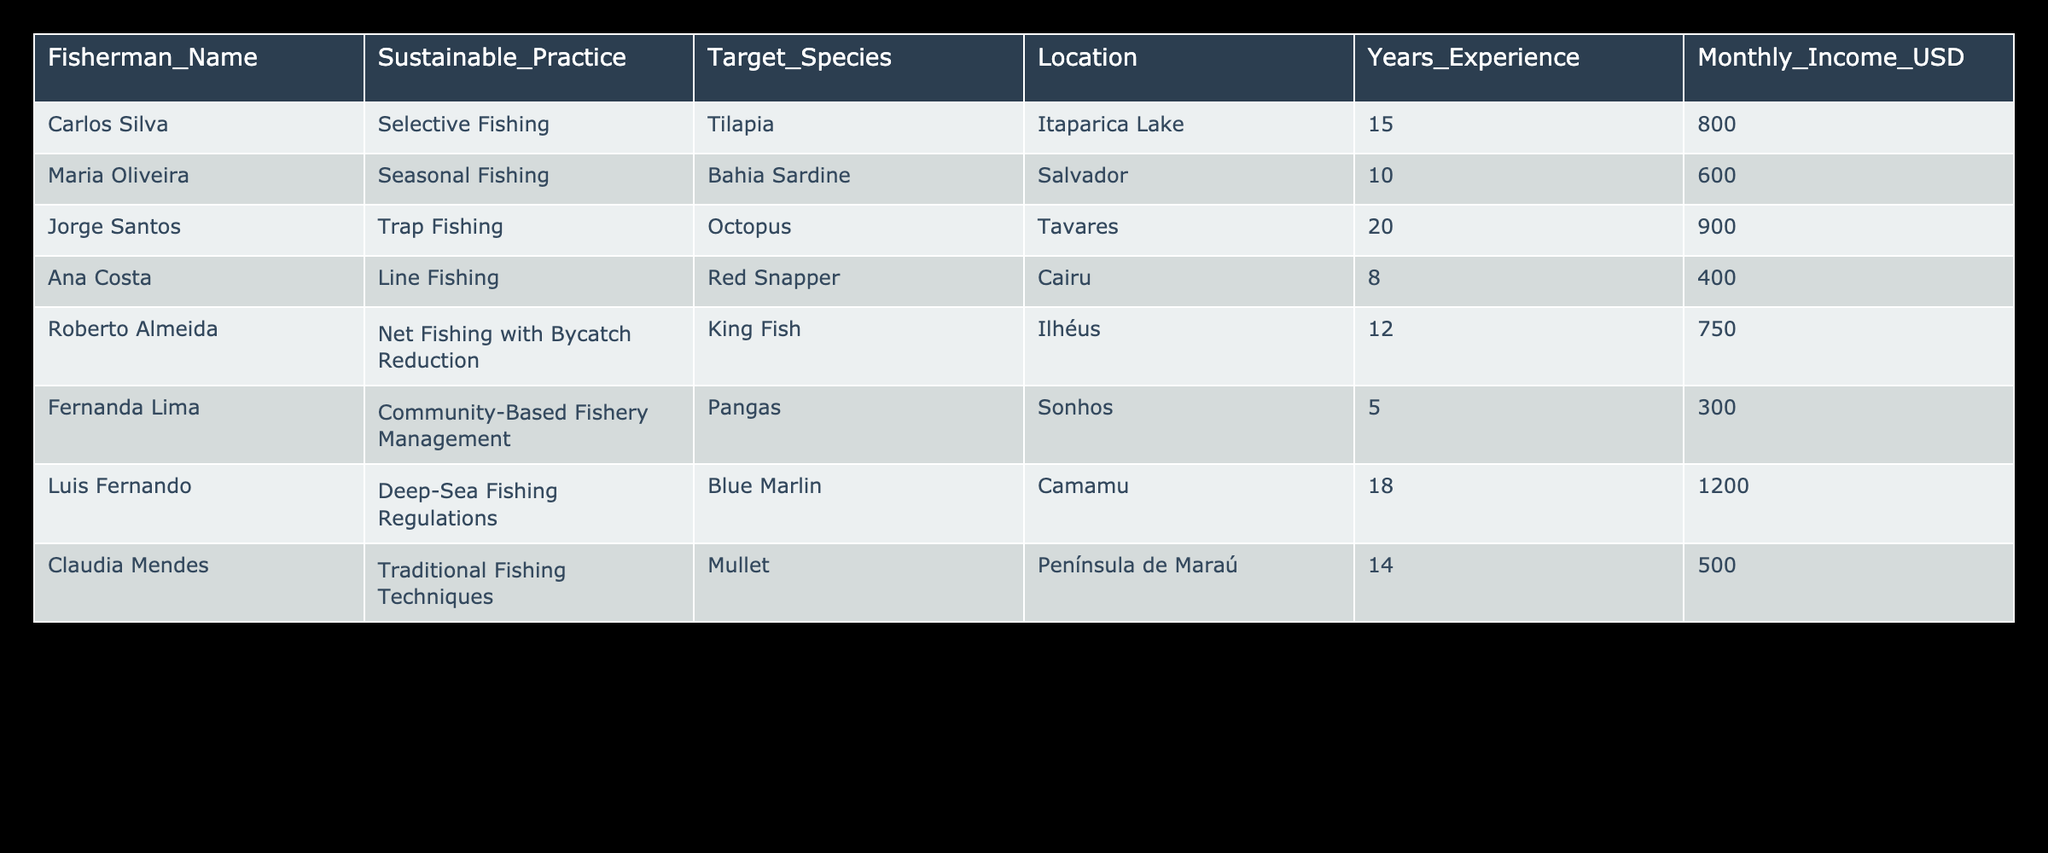What sustainable practice does Jorge Santos use? In the table, the "Sustainable_Practice" column lists the practice used by each fisherman. Looking at the row for Jorge Santos, it states he employs "Trap Fishing".
Answer: Trap Fishing Which location has the highest average monthly income among fishermen? To find the location with the highest average monthly income, we look at the "Monthly_Income_USD" column and calculate the average by location. Ilhéus has a monthly income of 750, while Camamu shows 1200, which is the highest compared to other locations.
Answer: Camamu Is it true that Ana Costa has more years of experience than Carlos Silva? In the table, Ana Costa has 8 years of experience while Carlos Silva has 15 years. Since 8 is less than 15, the statement is false.
Answer: No What is the total monthly income of fishermen who use Selective and Line Fishing? The relevant rows show that Carlos Silva earns 800 (Selective Fishing) and Ana Costa earns 400 (Line Fishing). Adding these incomes gives us 800 + 400 = 1200.
Answer: 1200 How many fishermen have more than 10 years of experience? By examining the "Years_Experience" column, we see the following: Carlos Silva (15), Jorge Santos (20), Roberto Almeida (12), and Luis Fernando (18) all have more than 10 years of experience. This gives us a total of 4 fishermen.
Answer: 4 What sustainable practice is associated with the lowest monthly income? Looking at the "Monthly_Income_USD" column, we can see that the lowest income listed is 300, which is associated with Fernanda Lima's practice of "Community-Based Fishery Management".
Answer: Community-Based Fishery Management How does the monthly income of traditional fishing techniques compare to selective fishing? From the table, Claudia Mendes using Traditional Fishing Techniques earns 500, while Carlos Silva using Selective Fishing earns 800. The comparison shows that selective fishing has a higher income by 300. Thus, 800 - 500 = 300.
Answer: Selective fishing earns 300 more What proportion of fishermen uses seasonal fishing? There are 8 fishermen listed in total and only Maria Oliveira uses Seasonal Fishing. The proportion is 1 out of 8, which simplifies to 0.125 or 12.5%.
Answer: 12.5% Is Luis Fernando the fisherman with the most experience in deep-sea fishing regulations? The table shows that Luis Fernando has 18 years of experience, and since there are no other fishermen listed under deep-sea fishing regulations, he is indeed the only one with that experience. Thus, the statement is true.
Answer: Yes 